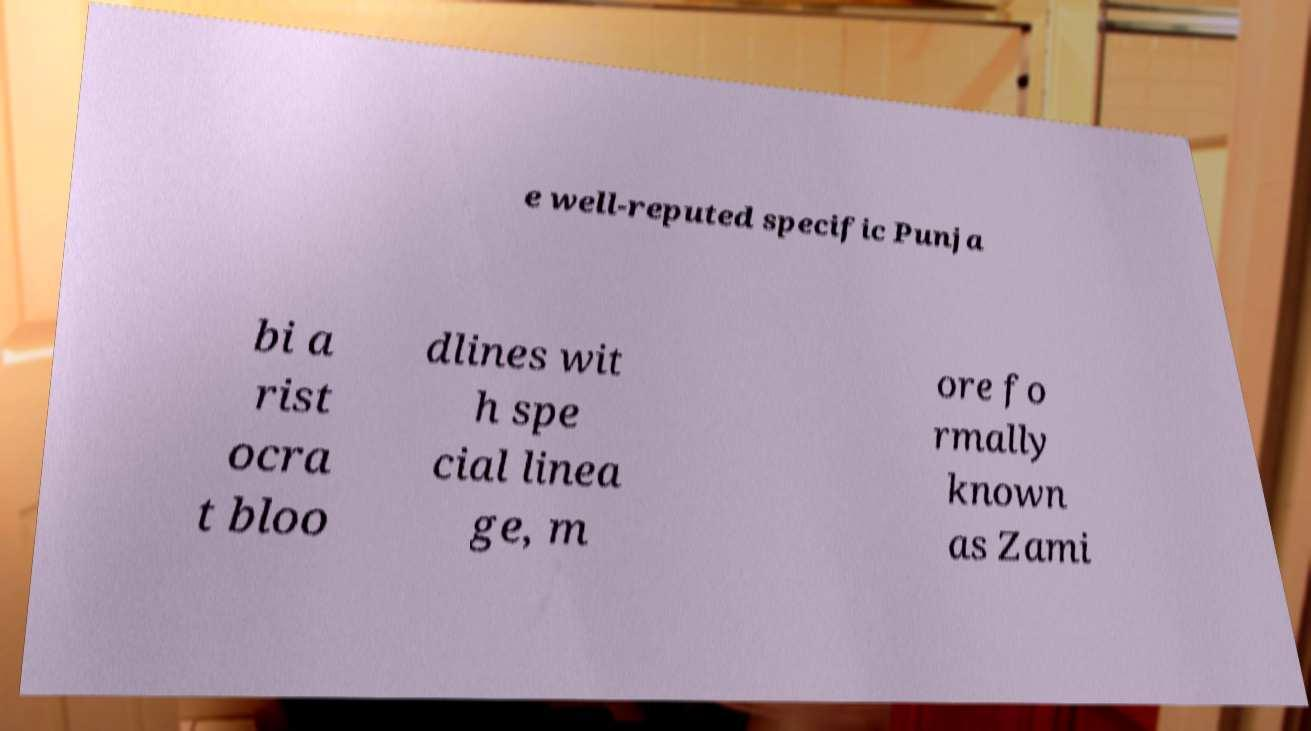I need the written content from this picture converted into text. Can you do that? e well-reputed specific Punja bi a rist ocra t bloo dlines wit h spe cial linea ge, m ore fo rmally known as Zami 